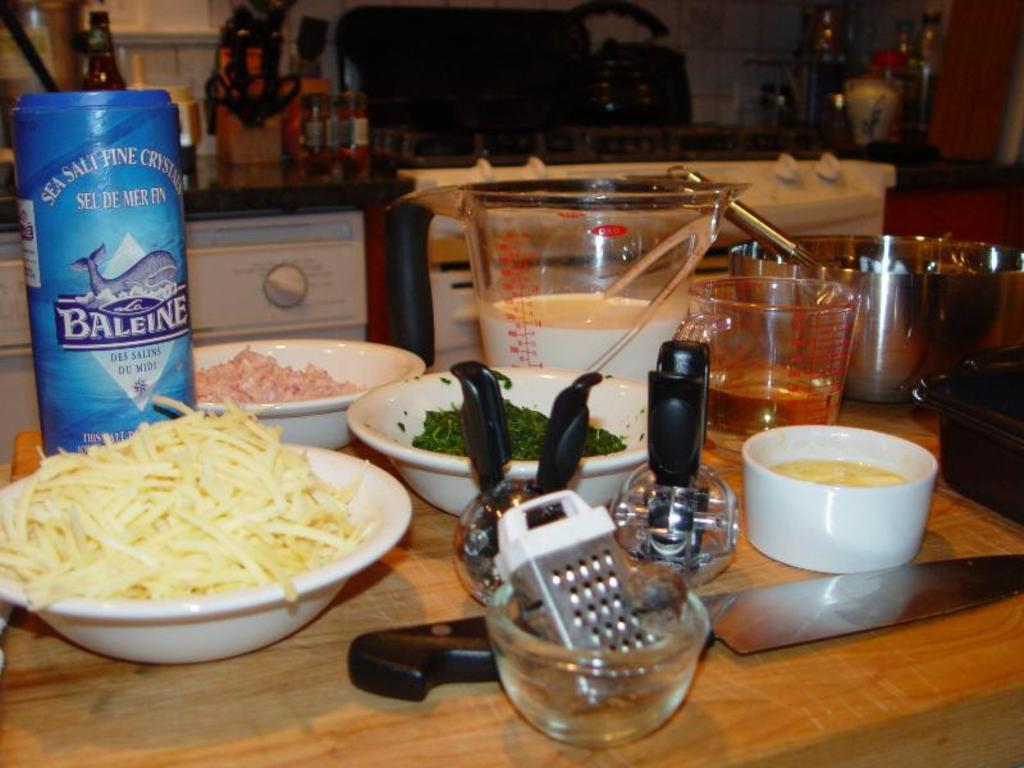What type of food can be seen in the image? There is food in the image, including meat and leafy vegetables. What container is present in the image? There is a bowl in the image. What utensil is visible in the image? There is a knife, a chop board, a glass, a spoon, and a bottle in the image. What appliance can be seen in the background of the image? There is a microwave oven in the background of the image. What other objects are present in the background of the image? There is a group of bottles in the background of the image. How much payment is required to purchase the farmer in the image? There is no farmer present in the image, so payment is not applicable. What type of things are being sold by the farmer in the image? There is no farmer or items for sale in the image. 